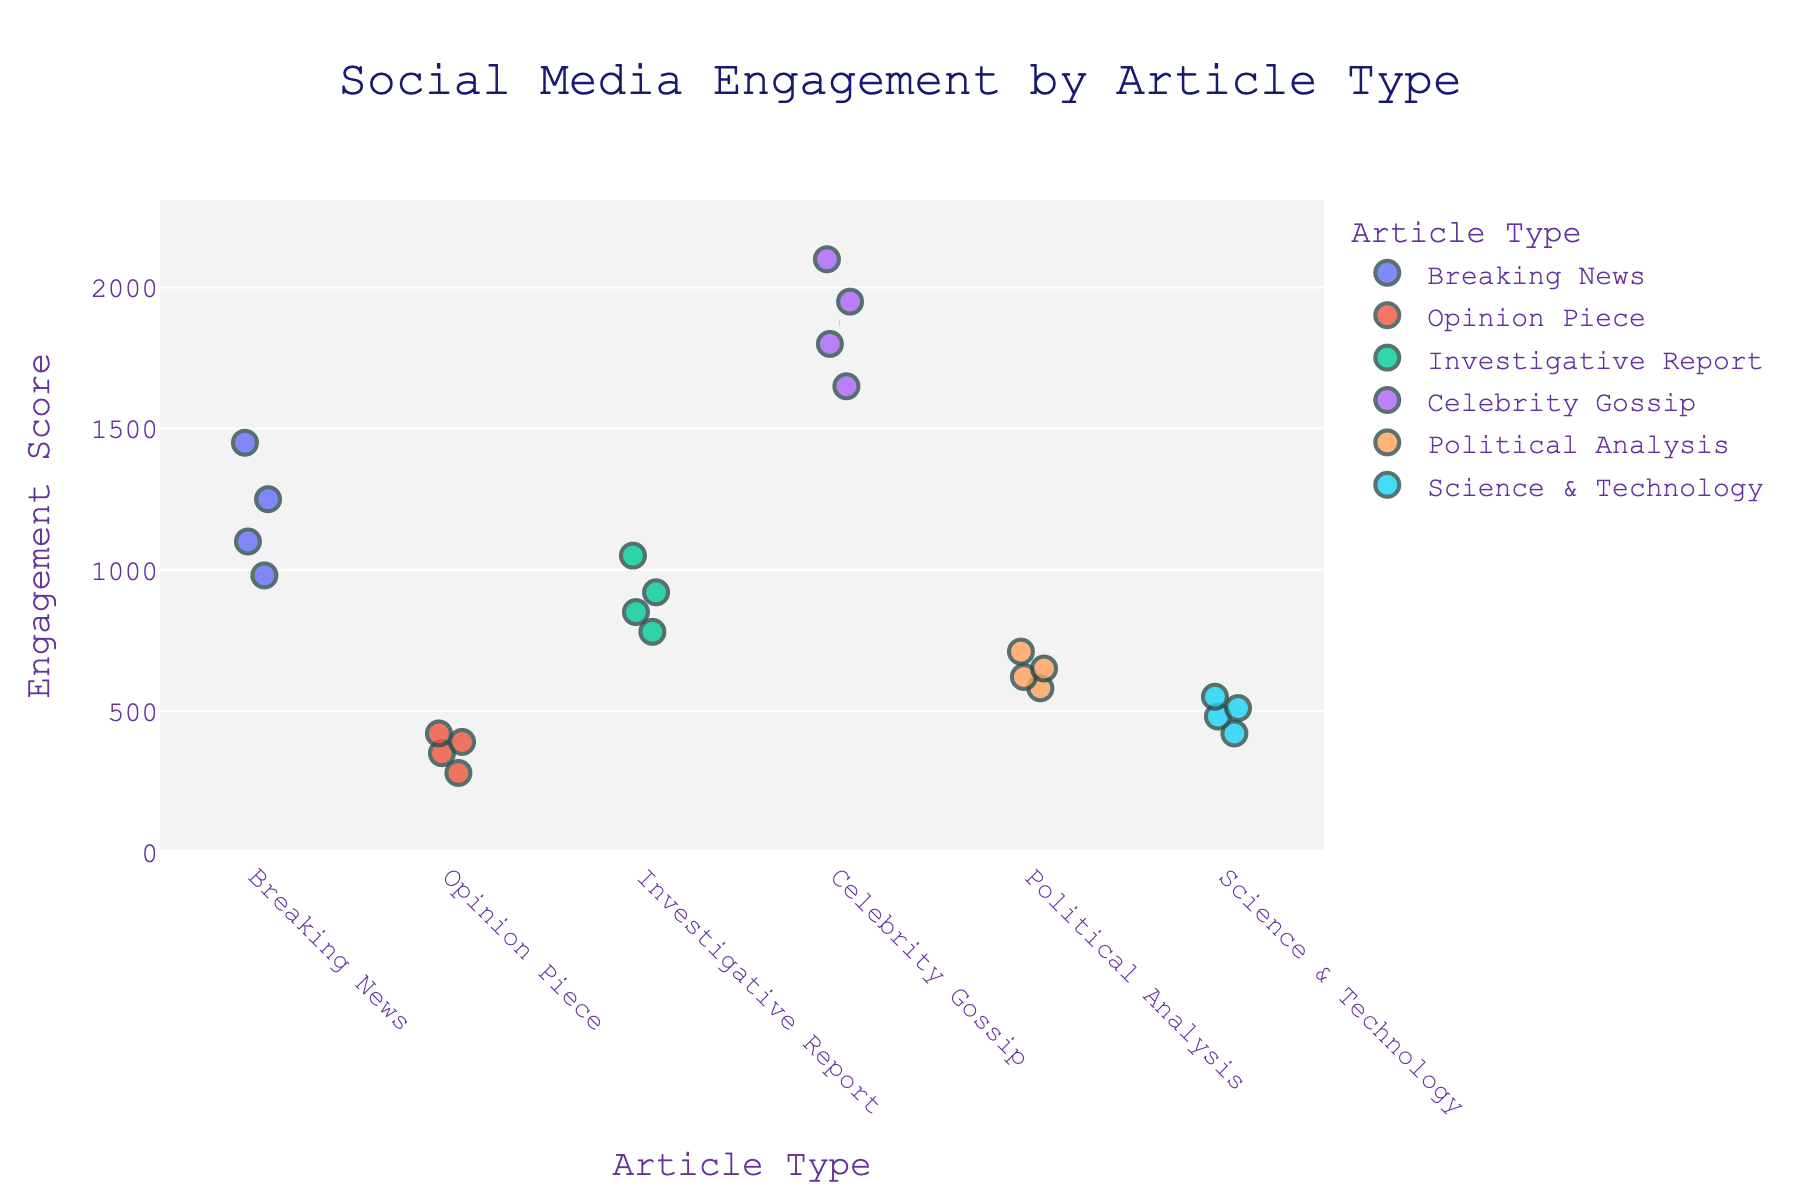what does the title of the plot say? The title of the plot is displayed at the top of the figure and provides a summary of the data being visualized.
Answer: Social Media Engagement by Article Type Which article type has the maximum engagement score and what is that score? Look for the article type with the highest data point on the y-axis. The "Celebrity Gossip" type has the highest point.
Answer: Celebrity Gossip, 2100 What are the labels on the x-axis and y-axis? The x-axis label is related to the types of news articles, and the y-axis label is related to the engagement scores.
Answer: Article Type, Engagement Score Which article type has the lowest engagement score? Identify the lowest data point on the y-axis, which corresponds to "Opinion Piece".
Answer: Opinion Piece How are the engagement scores for "Breaking News" distributed? Examine the spread of data points for "Breaking News" along the y-axis.
Answer: They are in the range of 980 to 1450 What is the average engagement score for "Opinion Piece"? Calculate the mean of the engagement scores for "Opinion Piece": (350 + 420 + 280 + 390) / 4 = 360.
Answer: 360 Which article type shows the most consistency in engagement scores? Look for the article type where data points are closely clustered around their mean line. "Science & Technology" appears to be the most consistent.
Answer: Science & Technology How does the engagement for "Investigative Report" compare to "Political Analysis"? Compare the spread and mean engagement scores of both article types. "Investigative Report" has a higher mean and wider spread than "Political Analysis".
Answer: Investigative Report, higher and wider spread What is the difference between the highest and lowest engagement scores for "Celebrity Gossip"? Subtract the lowest engagement score from the highest for "Celebrity Gossip": 2100 - 1650.
Answer: 450 Are there any visible trends or outliers in the data? Look for data points that are far from the majority of others. "Celebrity Gossip" has higher engagement which can be a trend, and no clear outliers are evident.
Answer: Higher engagement for Celebrity Gossip, no clear outliers 